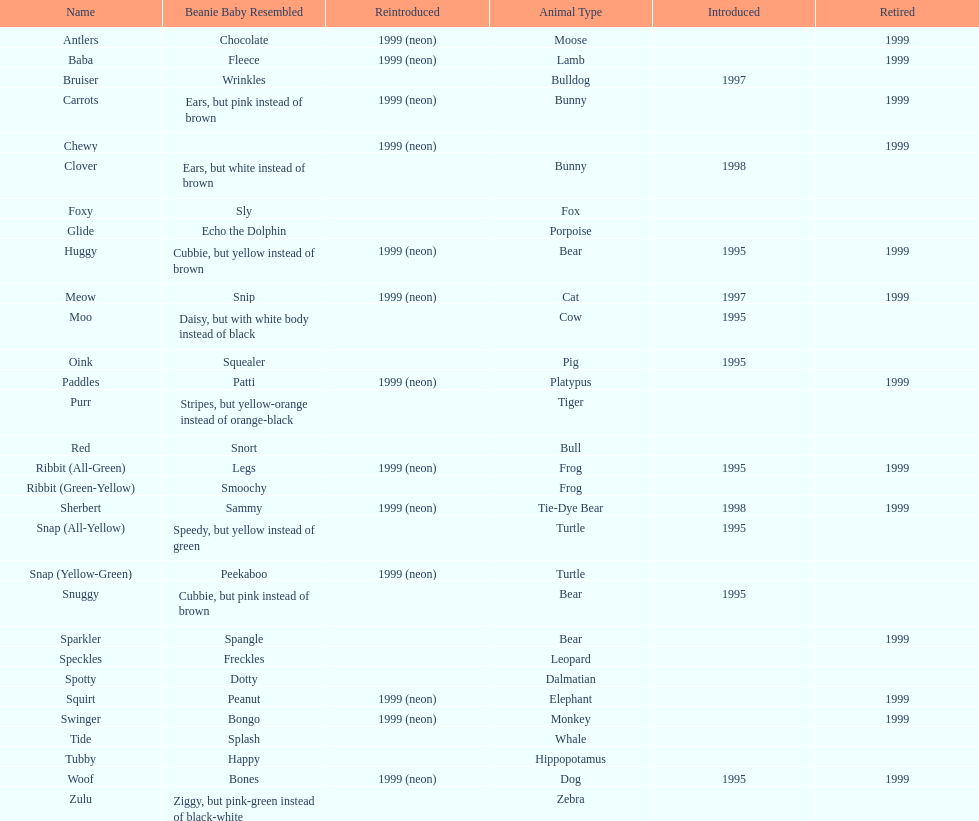How many total pillow pals were both reintroduced and retired in 1999? 12. 